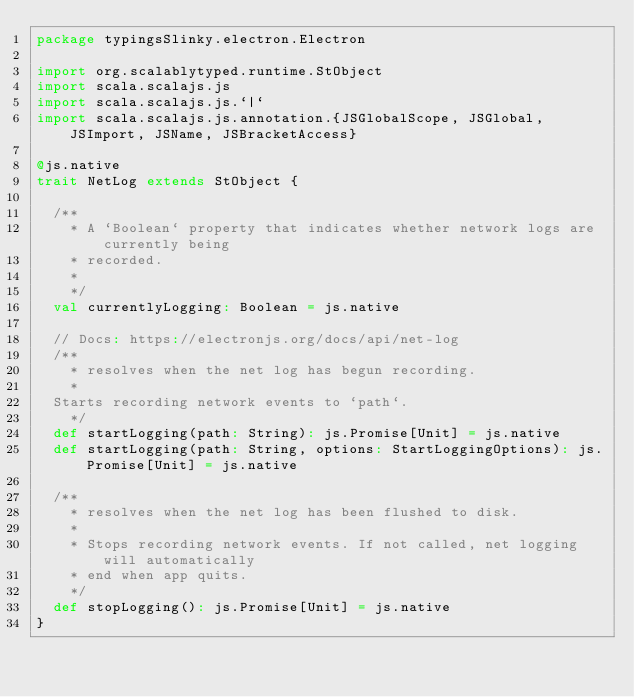<code> <loc_0><loc_0><loc_500><loc_500><_Scala_>package typingsSlinky.electron.Electron

import org.scalablytyped.runtime.StObject
import scala.scalajs.js
import scala.scalajs.js.`|`
import scala.scalajs.js.annotation.{JSGlobalScope, JSGlobal, JSImport, JSName, JSBracketAccess}

@js.native
trait NetLog extends StObject {
  
  /**
    * A `Boolean` property that indicates whether network logs are currently being
    * recorded.
    *
    */
  val currentlyLogging: Boolean = js.native
  
  // Docs: https://electronjs.org/docs/api/net-log
  /**
    * resolves when the net log has begun recording.
    * 
  Starts recording network events to `path`.
    */
  def startLogging(path: String): js.Promise[Unit] = js.native
  def startLogging(path: String, options: StartLoggingOptions): js.Promise[Unit] = js.native
  
  /**
    * resolves when the net log has been flushed to disk.
    *
    * Stops recording network events. If not called, net logging will automatically
    * end when app quits.
    */
  def stopLogging(): js.Promise[Unit] = js.native
}
</code> 